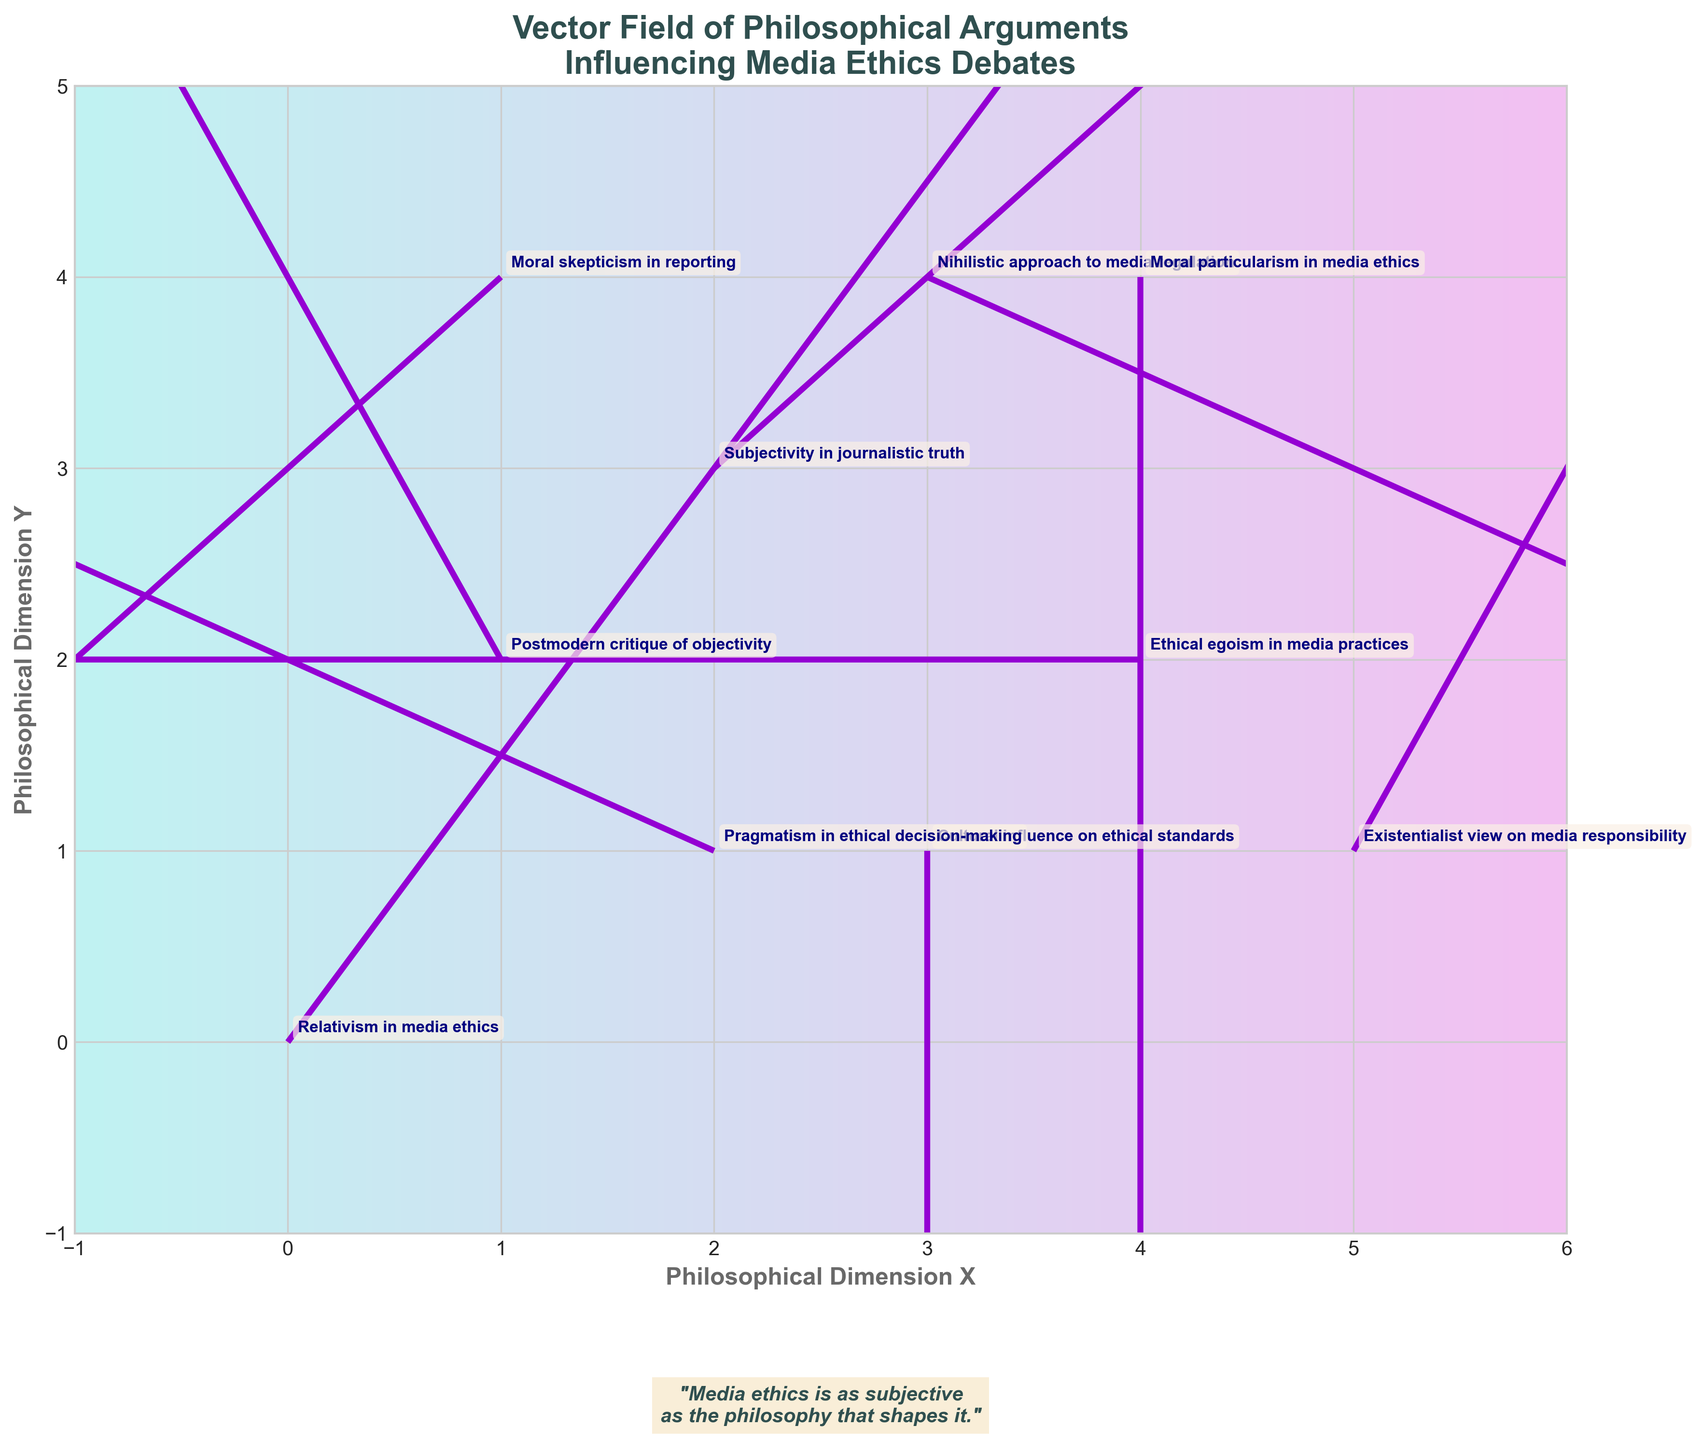What is the title of the figure? The title is located at the top of the figure and is typically written in a larger, bold font. It sets the context for what the figure represents.
Answer: Vector Field of Philosophical Arguments Influencing Media Ethics Debates What does the arrow at (1,2) represent? The arrows represent vectors, and each one is annotated with an argument label. The arrow at (1,2) is annotated with the argument it represents.
Answer: Postmodern critique of objectivity How many philosophical arguments are depicted in the plot? Counting each argument annotation in the figure provides the total number of philosophical arguments represented.
Answer: 10 Which argument has the longest vector? To find the longest vector, compare the magnitude of each vector by calculating √(u² + v²) for each arrow. The longest vector has the highest value.
Answer: Relativism in media ethics at (0, 0) with vector (2, 3) What are the coordinates of the argument "Nihilistic approach to media regulation"? Locate the text "Nihilistic approach to media regulation" on the figure, then read its coordinates from the plot.
Answer: (3, 4) Which argument has a vector pointing directly left? A vector pointing directly left would have a negative x-component (u) and a y-component (v) equal to zero. Identify the argument meeting these criteria.
Answer: Ethical egoism in media practices at (4,2) with vector (-2, 0) How many vectors have a negative y-component? Count the number of vectors that have a v (y-component) value less than zero.
Answer: 3 Which argument has the vector with the smallest magnitude? Calculate the magnitude √(u² + v²) for each vector, and identify the one with the smallest value.
Answer: Cultural influence on ethical standards at (3,1) with vector (0, -2) What does the background gradient on the plot depict? The background gradient typically does not add new information but aesthetically enhances the figure. It is a background feature to emphasize the plot's visual appeal.
Answer: A colorful gradient for visual enhancement Do any two vectors point exactly opposite directions? Two vectors are exactly opposite if one is the negative of the other, meaning (u1, v1) = -(u2, v2). Compare vectors to find such a pair.
Answer: Yes, "Ethical egoism in media practices" (4,2 with [-2,0]) and "Existentialist view on media responsibility" (5,1 with [1,2]) 